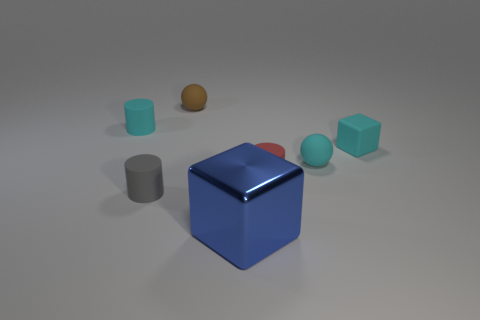Add 1 cyan cylinders. How many objects exist? 8 Subtract all purple objects. Subtract all tiny brown matte balls. How many objects are left? 6 Add 3 tiny matte cylinders. How many tiny matte cylinders are left? 6 Add 6 red rubber cylinders. How many red rubber cylinders exist? 7 Subtract all gray cylinders. How many cylinders are left? 2 Subtract all red matte cylinders. How many cylinders are left? 2 Subtract 0 red spheres. How many objects are left? 7 Subtract all cylinders. How many objects are left? 4 Subtract 2 balls. How many balls are left? 0 Subtract all purple cubes. Subtract all green cylinders. How many cubes are left? 2 